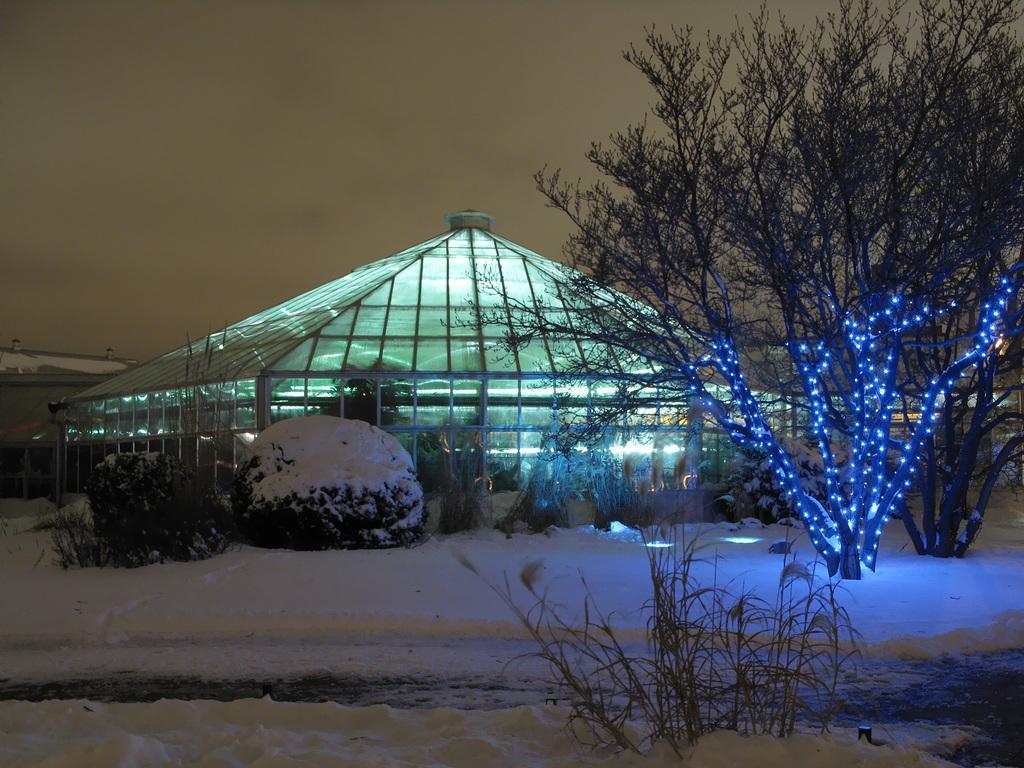How would you summarize this image in a sentence or two? In front of the image there are plants, bushes and trees decorated with lights on the snow surface, behind that there is a glass building with metal rods, behind that there are other buildings. 